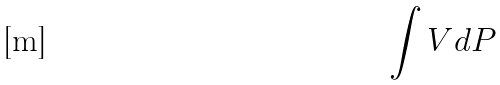<formula> <loc_0><loc_0><loc_500><loc_500>\int V d P</formula> 